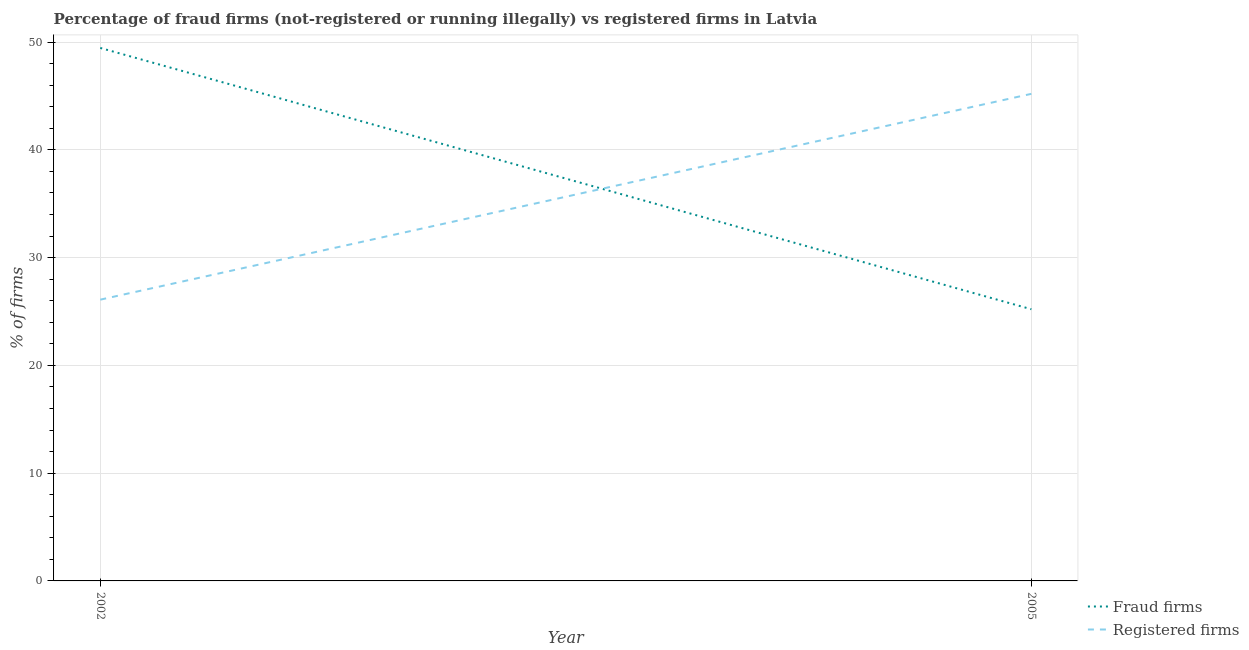How many different coloured lines are there?
Ensure brevity in your answer.  2. What is the percentage of registered firms in 2005?
Your answer should be very brief. 45.2. Across all years, what is the maximum percentage of fraud firms?
Your answer should be very brief. 49.46. Across all years, what is the minimum percentage of registered firms?
Keep it short and to the point. 26.1. In which year was the percentage of registered firms maximum?
Offer a very short reply. 2005. What is the total percentage of fraud firms in the graph?
Provide a succinct answer. 74.67. What is the difference between the percentage of fraud firms in 2002 and that in 2005?
Your response must be concise. 24.25. What is the difference between the percentage of fraud firms in 2005 and the percentage of registered firms in 2002?
Give a very brief answer. -0.89. What is the average percentage of fraud firms per year?
Your response must be concise. 37.34. In the year 2005, what is the difference between the percentage of fraud firms and percentage of registered firms?
Your answer should be compact. -19.99. In how many years, is the percentage of registered firms greater than 14 %?
Make the answer very short. 2. What is the ratio of the percentage of registered firms in 2002 to that in 2005?
Your response must be concise. 0.58. Is the percentage of fraud firms in 2002 less than that in 2005?
Provide a succinct answer. No. In how many years, is the percentage of registered firms greater than the average percentage of registered firms taken over all years?
Ensure brevity in your answer.  1. Does the percentage of fraud firms monotonically increase over the years?
Give a very brief answer. No. Is the percentage of fraud firms strictly greater than the percentage of registered firms over the years?
Provide a succinct answer. No. Is the percentage of fraud firms strictly less than the percentage of registered firms over the years?
Offer a terse response. No. How many lines are there?
Provide a succinct answer. 2. How many years are there in the graph?
Offer a terse response. 2. What is the difference between two consecutive major ticks on the Y-axis?
Ensure brevity in your answer.  10. Are the values on the major ticks of Y-axis written in scientific E-notation?
Make the answer very short. No. Where does the legend appear in the graph?
Ensure brevity in your answer.  Bottom right. What is the title of the graph?
Provide a short and direct response. Percentage of fraud firms (not-registered or running illegally) vs registered firms in Latvia. What is the label or title of the Y-axis?
Keep it short and to the point. % of firms. What is the % of firms in Fraud firms in 2002?
Your answer should be compact. 49.46. What is the % of firms of Registered firms in 2002?
Give a very brief answer. 26.1. What is the % of firms in Fraud firms in 2005?
Keep it short and to the point. 25.21. What is the % of firms in Registered firms in 2005?
Offer a terse response. 45.2. Across all years, what is the maximum % of firms in Fraud firms?
Provide a succinct answer. 49.46. Across all years, what is the maximum % of firms in Registered firms?
Make the answer very short. 45.2. Across all years, what is the minimum % of firms of Fraud firms?
Your response must be concise. 25.21. Across all years, what is the minimum % of firms in Registered firms?
Make the answer very short. 26.1. What is the total % of firms in Fraud firms in the graph?
Provide a short and direct response. 74.67. What is the total % of firms in Registered firms in the graph?
Ensure brevity in your answer.  71.3. What is the difference between the % of firms in Fraud firms in 2002 and that in 2005?
Your answer should be compact. 24.25. What is the difference between the % of firms of Registered firms in 2002 and that in 2005?
Your answer should be very brief. -19.1. What is the difference between the % of firms of Fraud firms in 2002 and the % of firms of Registered firms in 2005?
Offer a terse response. 4.26. What is the average % of firms of Fraud firms per year?
Your answer should be compact. 37.34. What is the average % of firms in Registered firms per year?
Offer a very short reply. 35.65. In the year 2002, what is the difference between the % of firms in Fraud firms and % of firms in Registered firms?
Your response must be concise. 23.36. In the year 2005, what is the difference between the % of firms in Fraud firms and % of firms in Registered firms?
Ensure brevity in your answer.  -19.99. What is the ratio of the % of firms in Fraud firms in 2002 to that in 2005?
Give a very brief answer. 1.96. What is the ratio of the % of firms in Registered firms in 2002 to that in 2005?
Offer a very short reply. 0.58. What is the difference between the highest and the second highest % of firms in Fraud firms?
Offer a very short reply. 24.25. What is the difference between the highest and the lowest % of firms in Fraud firms?
Keep it short and to the point. 24.25. 